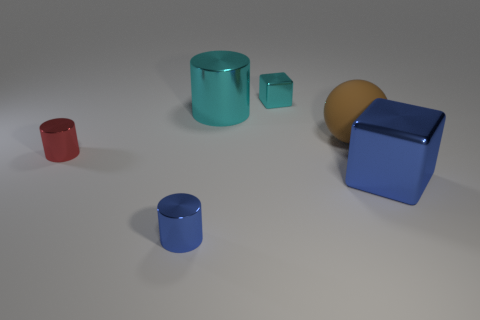Subtract all tiny metal cylinders. How many cylinders are left? 1 Add 3 big red cubes. How many objects exist? 9 Subtract all spheres. How many objects are left? 5 Subtract all brown cylinders. Subtract all red spheres. How many cylinders are left? 3 Add 1 small blue cylinders. How many small blue cylinders are left? 2 Add 1 small blue rubber spheres. How many small blue rubber spheres exist? 1 Subtract 0 red blocks. How many objects are left? 6 Subtract all big objects. Subtract all tiny cyan cubes. How many objects are left? 2 